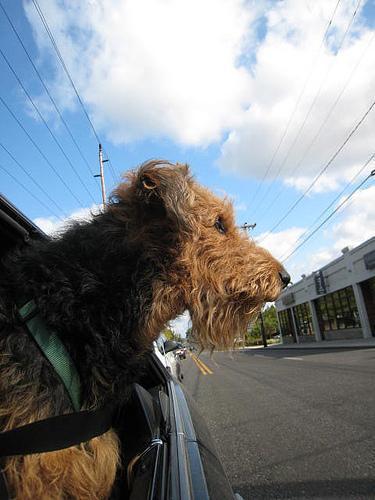How many dogs are there?
Give a very brief answer. 1. How many dogs are seen?
Give a very brief answer. 1. 